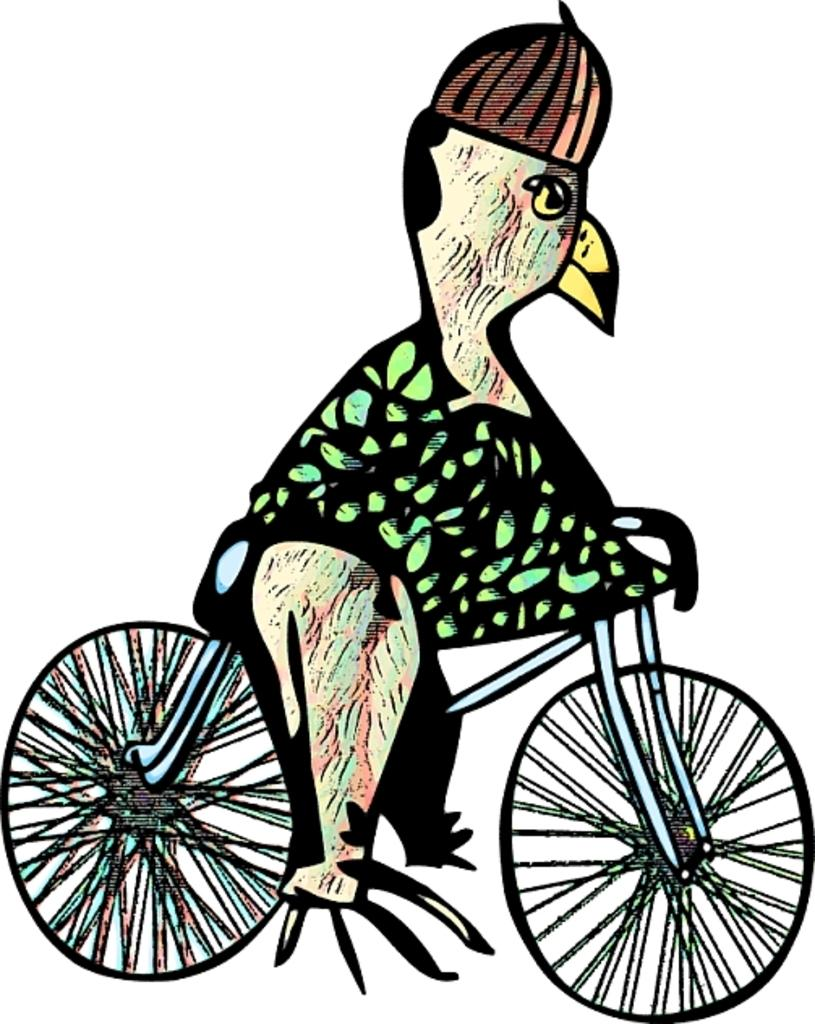What is the main subject of the image? The image contains a sketch. What type of animal is depicted in the sketch? There is a bird in the sketch. What is the bird wearing in the sketch? The bird is wearing a cap in the sketch. What is the bird doing in the sketch? The bird is on a bicycle in the sketch. What color is the background of the sketch? The background of the sketch is white. Can you see any buildings or the ocean in the background of the sketch? No, the background of the sketch is white, and there are no buildings or ocean depicted. 